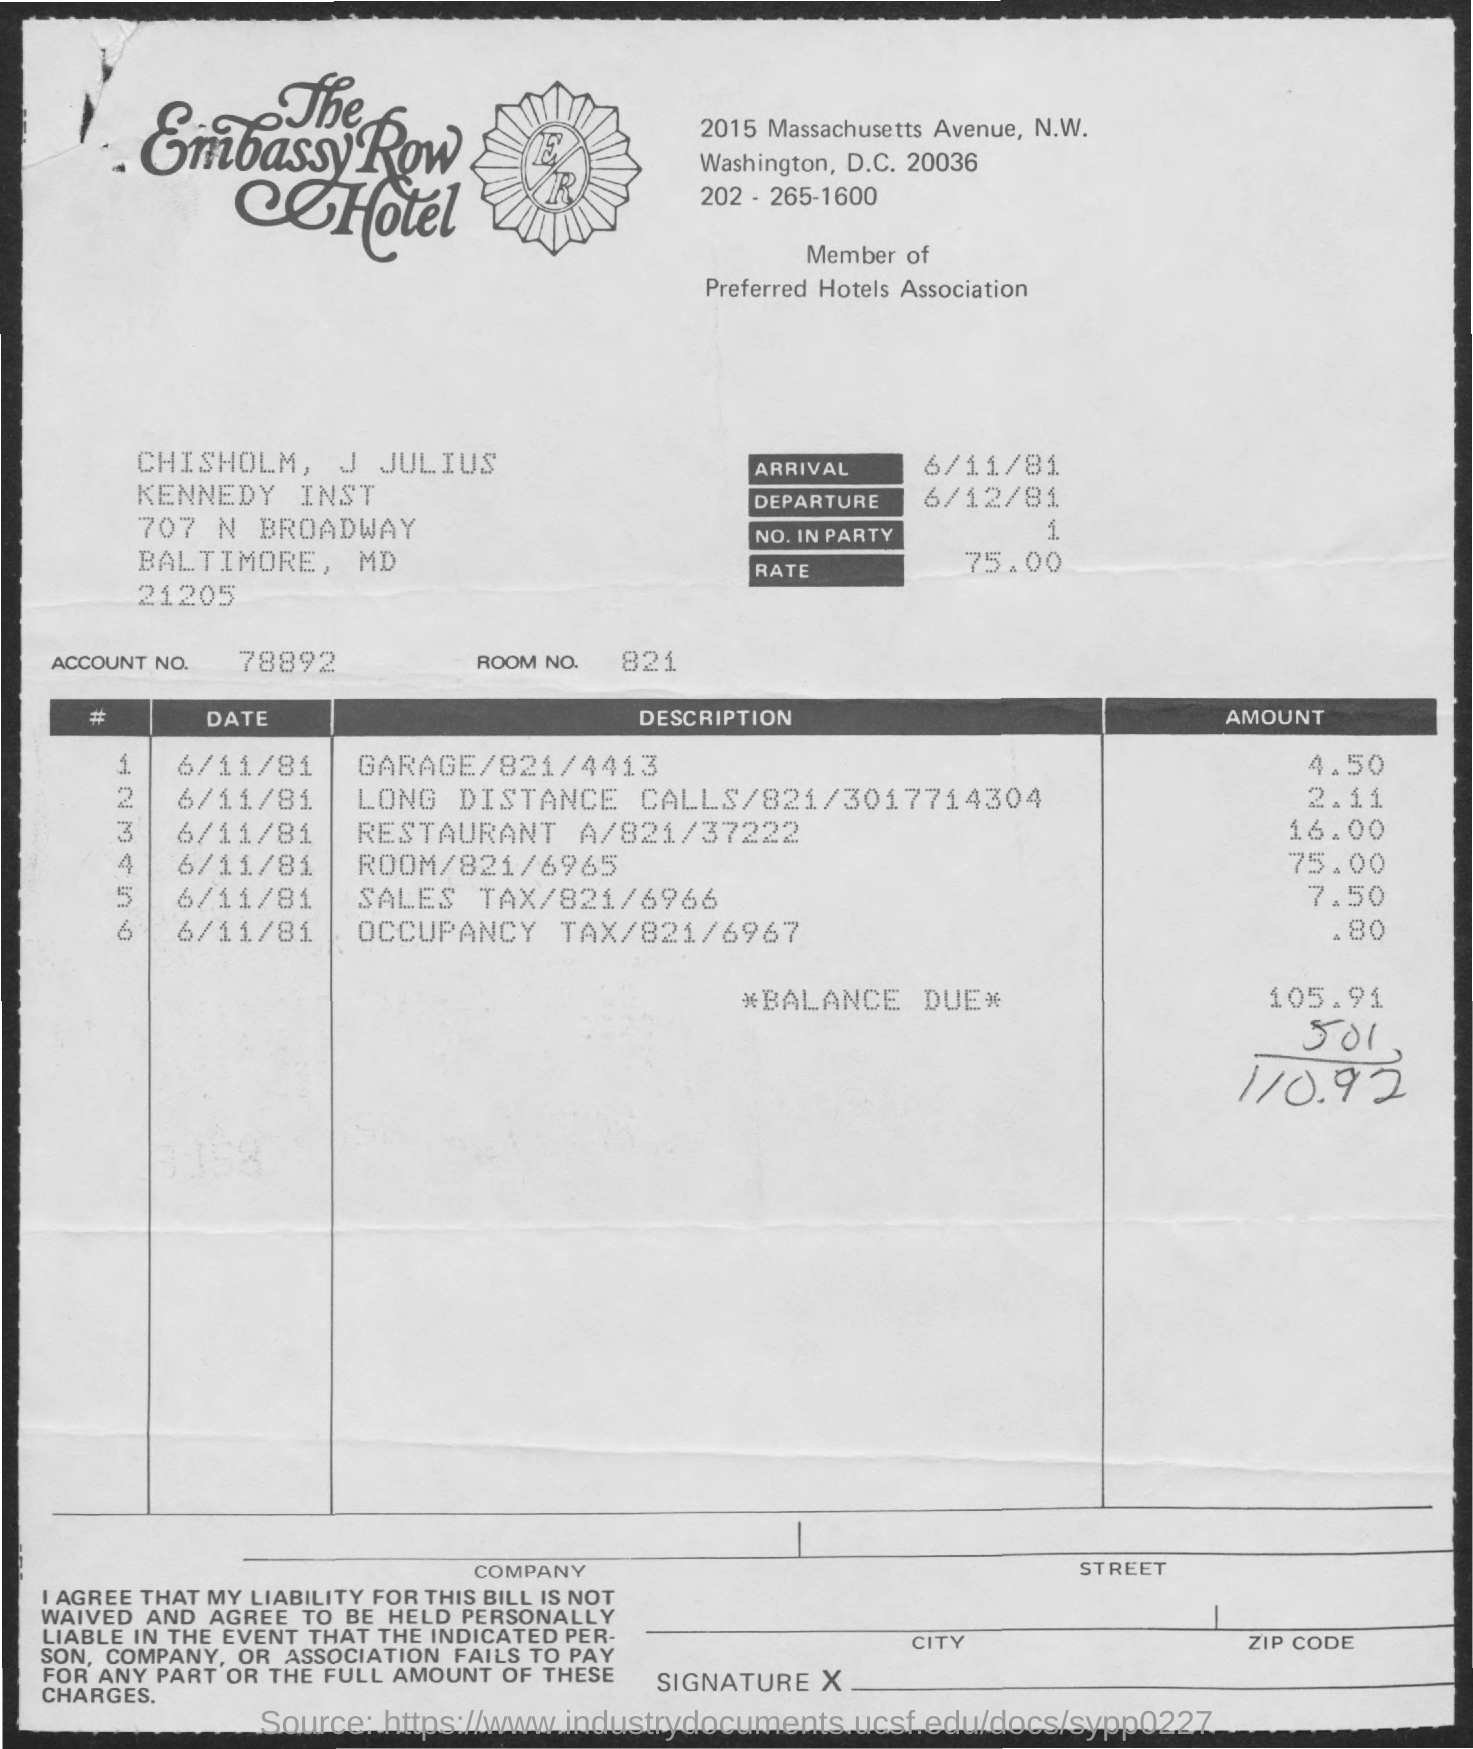When is the arrival?
Provide a succinct answer. 6/11/81. When is the departure?
Ensure brevity in your answer.  6/12/81. What is the rate?
Offer a terse response. 75.00. What is the Account No.?
Ensure brevity in your answer.  78892. What is the Room No.?
Offer a terse response. 821. What is the Amount for garage/821/4413?
Make the answer very short. 4.50. What is the Amount for Long distance calls/821/3017714304?
Provide a short and direct response. 2.11. What is the Amount for Restaurant A/821/37222
Make the answer very short. 16.00. What is the Amount for Room/821/6965?
Make the answer very short. 75.00. 